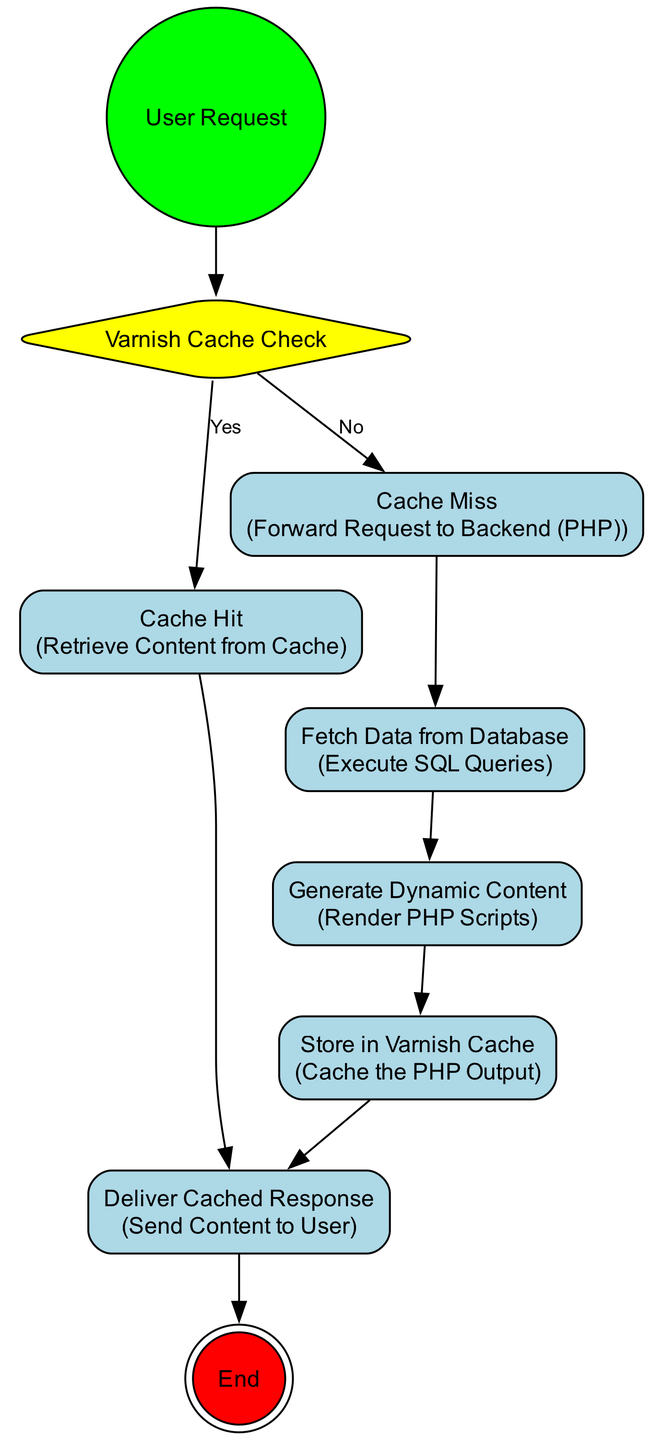What is the first node in the diagram? The first node in the diagram represents the starting point of the workflow and is named "User Request". It indicates the initiation of the caching workflow.
Answer: User Request How many activities are there in total? An activity is represented by a distinct action in the diagram. By counting the nodes categorized as activities, we find that there are five activities: "Retrieve Content from Cache," "Forward Request to Backend (PHP)," "Execute SQL Queries," "Render PHP Scripts," and "Cache the PHP Output."
Answer: 5 What happens if the request is not cached? If the request is not cached, the diagram shows that the workflow moves to "Cache Miss," leading to the next action to "Fetch Data from Database." This sequential flow illustrates the response to a cache miss.
Answer: Forward Request to Backend (PHP) What is the last action before reaching the final node? The last action in the workflow before reaching the final node "End" is "Deliver Cached Response." This action is where the cached content is sent back to the user after being retrieved or generated.
Answer: Deliver Cached Response How does the flow proceed from "Cache Miss"? From "Cache Miss," the flow proceeds to "Fetch Data from Database," which then transitions to "Generate Dynamic Content." This series of actions represents handling the request when the requested content is not in the cache.
Answer: Fetch Data from Database What type of node is used to represent decisions, and how many are there? The type of node used to represent decisions is a "Decision Node," which is depicted as a diamond shape in the diagram. There is one decision node present, labeled "Varnish Cache Check."
Answer: 1 Which node indicates the retrieval of content from the cache? The node that represents the retrieval of content from the cache is labeled "Cache Hit." This node follows the decision made in "Varnish Cache Check" if the request is found in the cache.
Answer: Cache Hit What action follows the generation of dynamic content? After the "Generate Dynamic Content" action, the next action is "Store in Varnish Cache." This indicates that once the dynamic content is created, it is then stored in the cache for future requests.
Answer: Store in Varnish Cache 